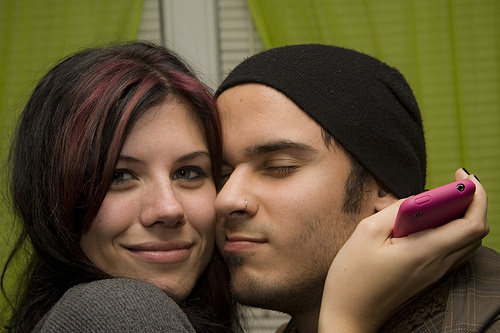Describe the objects in this image and their specific colors. I can see people in olive, black, maroon, and gray tones, people in olive, black, gray, maroon, and tan tones, and cell phone in olive, maroon, black, salmon, and brown tones in this image. 